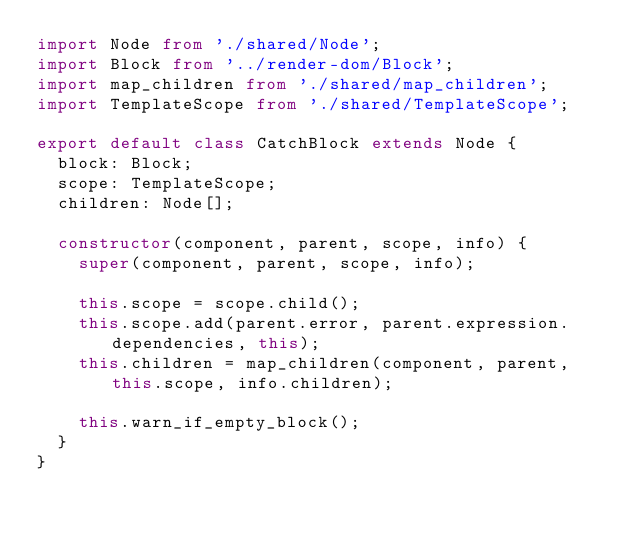Convert code to text. <code><loc_0><loc_0><loc_500><loc_500><_TypeScript_>import Node from './shared/Node';
import Block from '../render-dom/Block';
import map_children from './shared/map_children';
import TemplateScope from './shared/TemplateScope';

export default class CatchBlock extends Node {
	block: Block;
	scope: TemplateScope;
	children: Node[];

	constructor(component, parent, scope, info) {
		super(component, parent, scope, info);

		this.scope = scope.child();
		this.scope.add(parent.error, parent.expression.dependencies, this);
		this.children = map_children(component, parent, this.scope, info.children);

		this.warn_if_empty_block();
	}
}</code> 